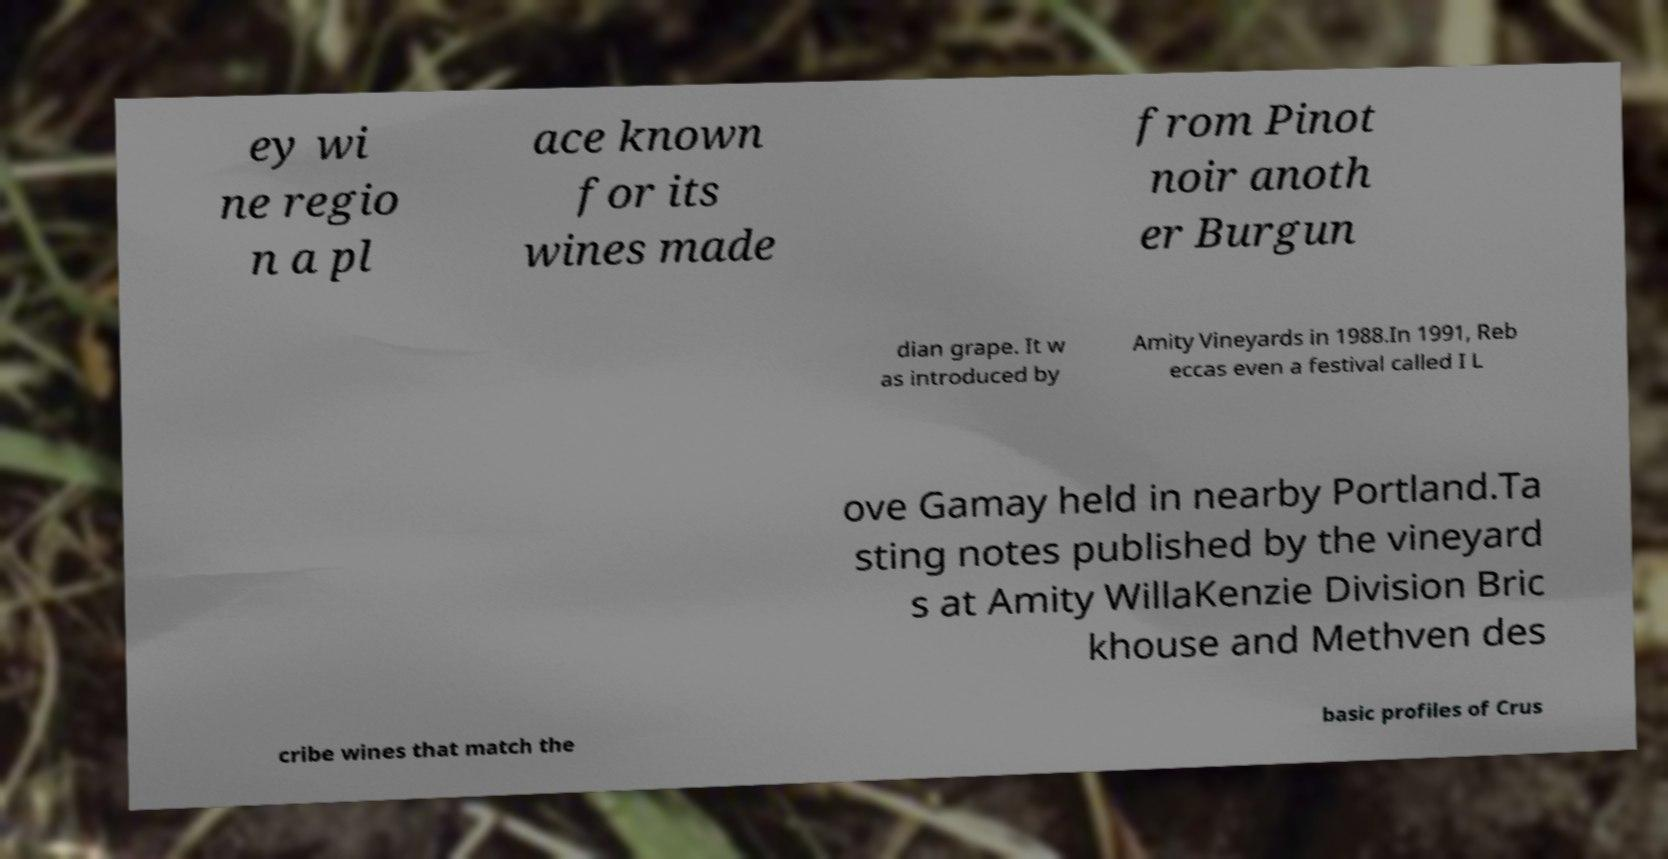Could you extract and type out the text from this image? ey wi ne regio n a pl ace known for its wines made from Pinot noir anoth er Burgun dian grape. It w as introduced by Amity Vineyards in 1988.In 1991, Reb eccas even a festival called I L ove Gamay held in nearby Portland.Ta sting notes published by the vineyard s at Amity WillaKenzie Division Bric khouse and Methven des cribe wines that match the basic profiles of Crus 